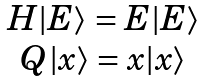Convert formula to latex. <formula><loc_0><loc_0><loc_500><loc_500>\begin{array} { c } H | E \rangle = E | E \rangle \\ Q | x \rangle = x | x \rangle \end{array}</formula> 